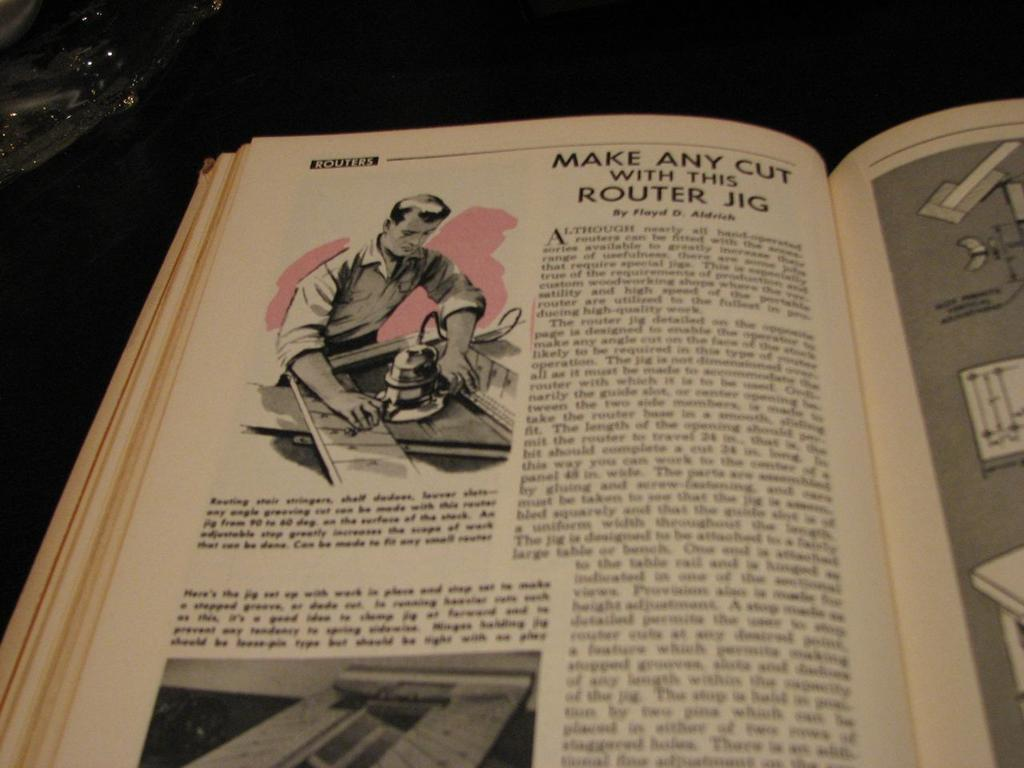<image>
Write a terse but informative summary of the picture. A vintage looking book that has a passage about how to make any cut with this router jig. 